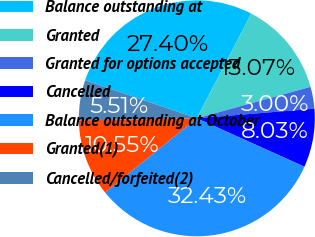Convert chart to OTSL. <chart><loc_0><loc_0><loc_500><loc_500><pie_chart><fcel>Balance outstanding at<fcel>Granted<fcel>Granted for options accepted<fcel>Cancelled<fcel>Balance outstanding at October<fcel>Granted(1)<fcel>Cancelled/forfeited(2)<nl><fcel>27.4%<fcel>13.07%<fcel>3.0%<fcel>8.03%<fcel>32.43%<fcel>10.55%<fcel>5.51%<nl></chart> 